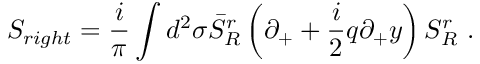Convert formula to latex. <formula><loc_0><loc_0><loc_500><loc_500>S _ { r i g h t } = \frac { i } { \pi } \int d ^ { 2 } \sigma \bar { S } _ { R } ^ { r } \left ( \partial _ { + } + \frac { i } { 2 } q \partial _ { + } y \right ) S _ { R } ^ { r } \ .</formula> 